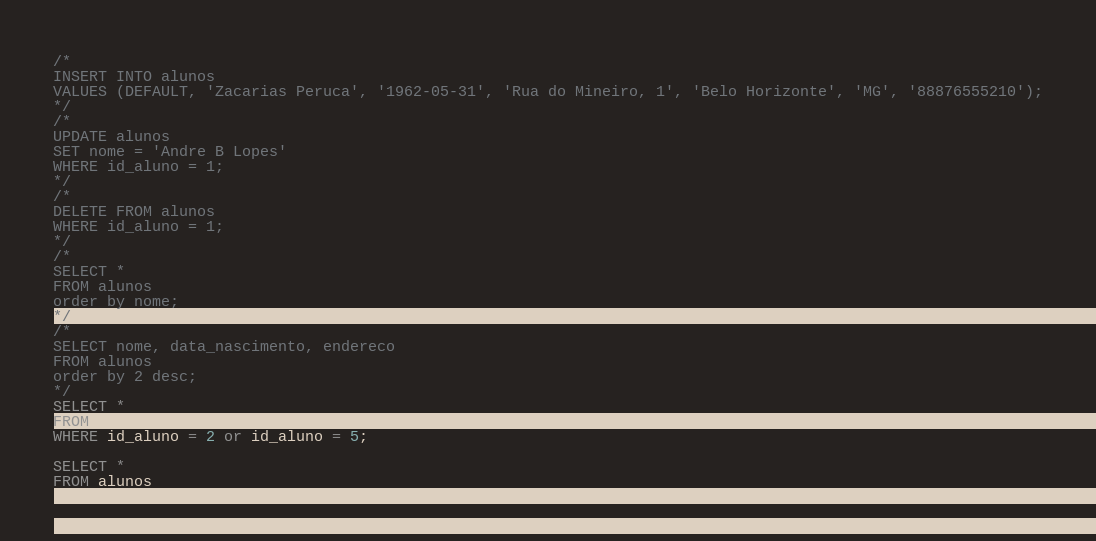<code> <loc_0><loc_0><loc_500><loc_500><_SQL_>/*
INSERT INTO alunos
VALUES (DEFAULT, 'Zacarias Peruca', '1962-05-31', 'Rua do Mineiro, 1', 'Belo Horizonte', 'MG', '88876555210');
*/
/*
UPDATE alunos
SET nome = 'Andre B Lopes'
WHERE id_aluno = 1;
*/
/*
DELETE FROM alunos
WHERE id_aluno = 1;
*/
/*
SELECT *
FROM alunos
order by nome;
*/
/*
SELECT nome, data_nascimento, endereco
FROM alunos
order by 2 desc;
*/
SELECT *
FROM alunos
WHERE id_aluno = 2 or id_aluno = 5;

SELECT *
FROM alunos</code> 